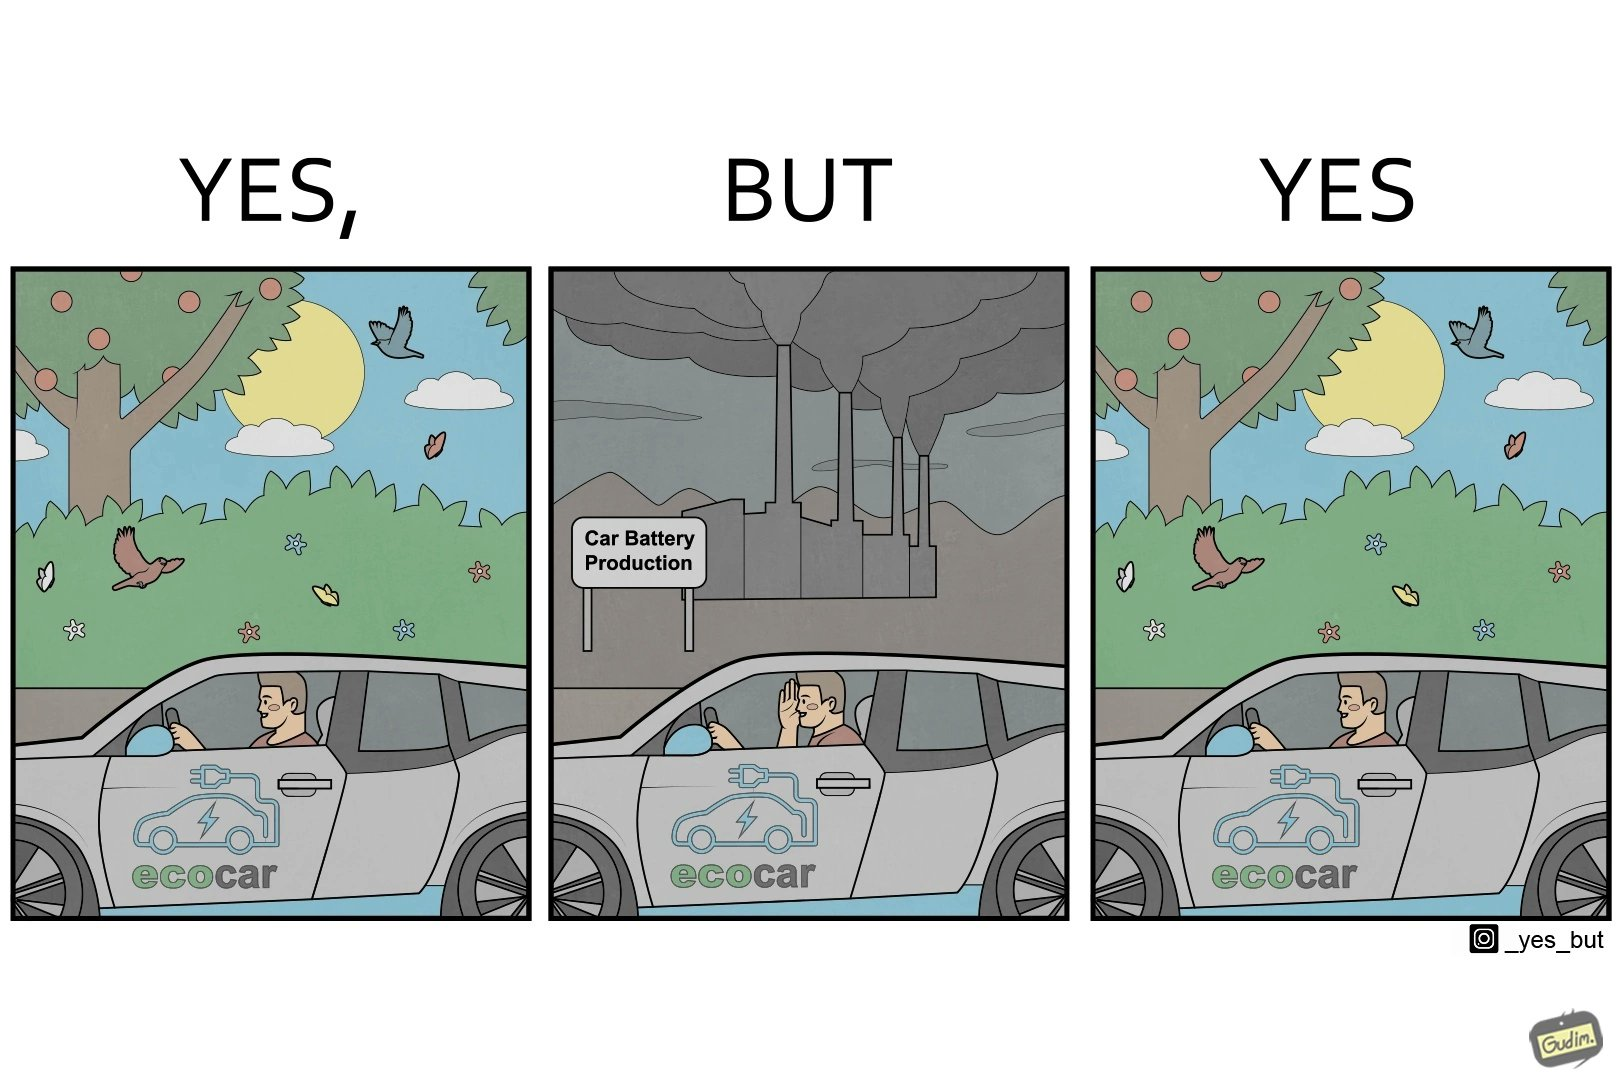Describe the satirical element in this image. The images are ironic since they show how even though electric powered cars are touted to be a game changer in the automotive industry and claims are made that they will make the world a greener and cleaner place to live in, the reality is quite different. Battery production causes vast amounts of pollution making such claims very doubtful 